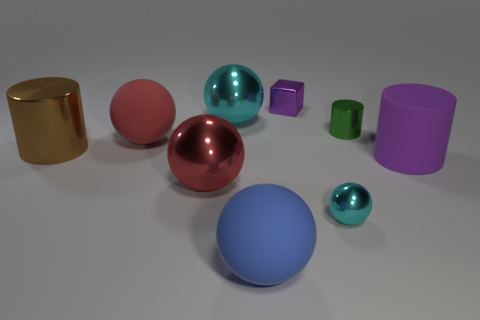There is a cyan shiny thing that is in front of the large cylinder on the left side of the tiny green object that is left of the purple rubber cylinder; what size is it?
Ensure brevity in your answer.  Small. What size is the matte thing that is the same color as the tiny block?
Provide a succinct answer. Large. There is a large matte object that is behind the small cyan metal sphere and on the left side of the small shiny block; what shape is it?
Make the answer very short. Sphere. Do the green object and the purple object in front of the green cylinder have the same shape?
Provide a short and direct response. Yes. What is the material of the tiny block that is the same color as the large matte cylinder?
Offer a terse response. Metal. Is the shape of the brown shiny thing the same as the purple rubber thing?
Keep it short and to the point. Yes. What is the size of the ball that is in front of the small cyan metallic thing?
Your response must be concise. Large. Is there a large rubber cylinder that has the same color as the metal block?
Your response must be concise. Yes. There is a metallic ball behind the green cylinder; does it have the same size as the tiny ball?
Ensure brevity in your answer.  No. The small shiny thing behind the cyan ball that is behind the tiny cylinder is what color?
Your response must be concise. Purple. 